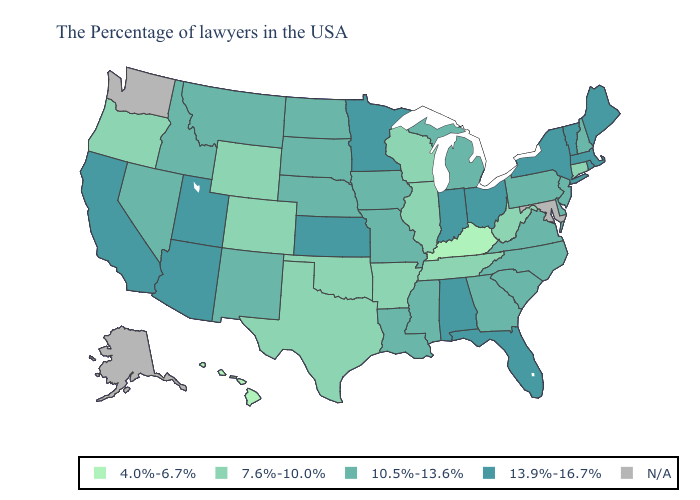Is the legend a continuous bar?
Short answer required. No. Which states have the lowest value in the USA?
Be succinct. Kentucky, Hawaii. Name the states that have a value in the range 13.9%-16.7%?
Quick response, please. Maine, Massachusetts, Rhode Island, Vermont, New York, Ohio, Florida, Indiana, Alabama, Minnesota, Kansas, Utah, Arizona, California. Does the first symbol in the legend represent the smallest category?
Quick response, please. Yes. Among the states that border Ohio , does Kentucky have the lowest value?
Give a very brief answer. Yes. Name the states that have a value in the range 13.9%-16.7%?
Keep it brief. Maine, Massachusetts, Rhode Island, Vermont, New York, Ohio, Florida, Indiana, Alabama, Minnesota, Kansas, Utah, Arizona, California. What is the value of Maryland?
Keep it brief. N/A. What is the lowest value in the West?
Quick response, please. 4.0%-6.7%. What is the lowest value in the USA?
Concise answer only. 4.0%-6.7%. Does the first symbol in the legend represent the smallest category?
Keep it brief. Yes. What is the value of Hawaii?
Concise answer only. 4.0%-6.7%. What is the lowest value in the South?
Quick response, please. 4.0%-6.7%. What is the value of Washington?
Give a very brief answer. N/A. Name the states that have a value in the range 4.0%-6.7%?
Write a very short answer. Kentucky, Hawaii. What is the value of Nebraska?
Answer briefly. 10.5%-13.6%. 